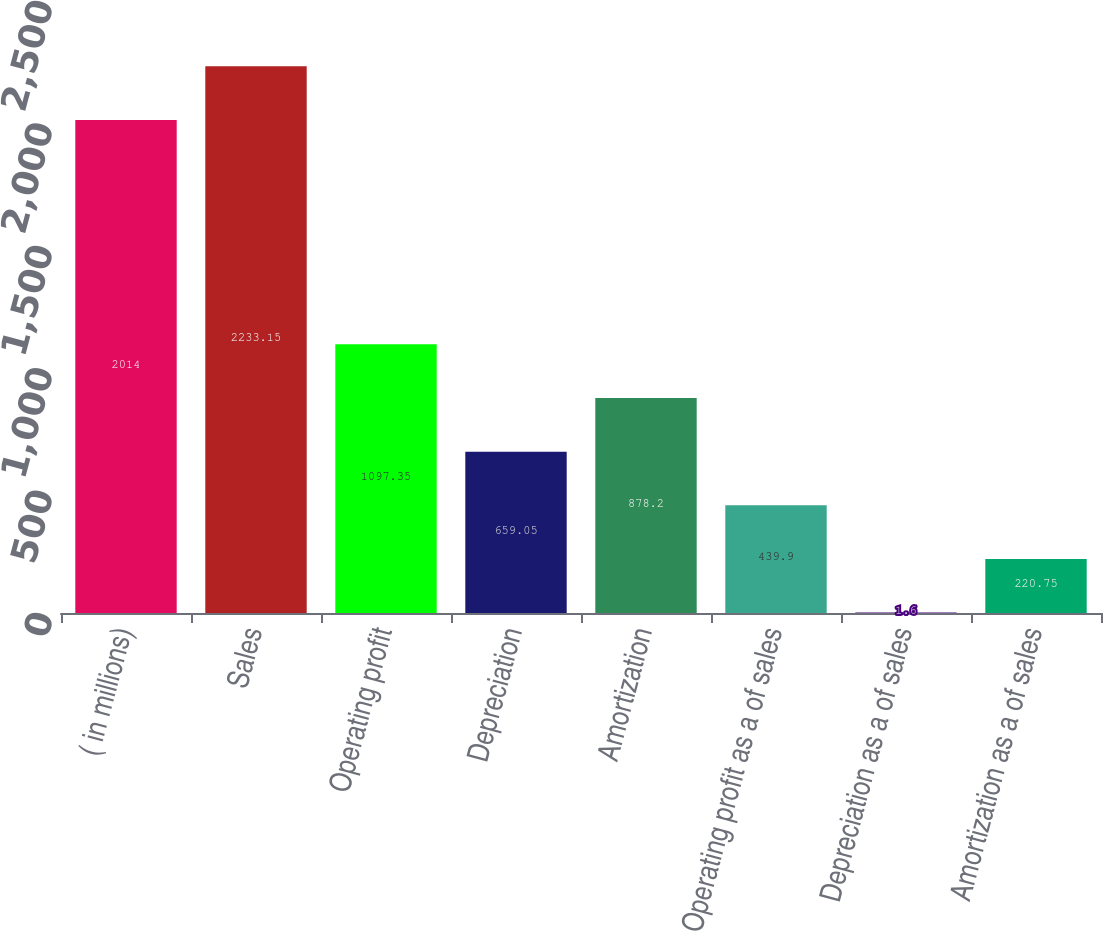Convert chart to OTSL. <chart><loc_0><loc_0><loc_500><loc_500><bar_chart><fcel>( in millions)<fcel>Sales<fcel>Operating profit<fcel>Depreciation<fcel>Amortization<fcel>Operating profit as a of sales<fcel>Depreciation as a of sales<fcel>Amortization as a of sales<nl><fcel>2014<fcel>2233.15<fcel>1097.35<fcel>659.05<fcel>878.2<fcel>439.9<fcel>1.6<fcel>220.75<nl></chart> 